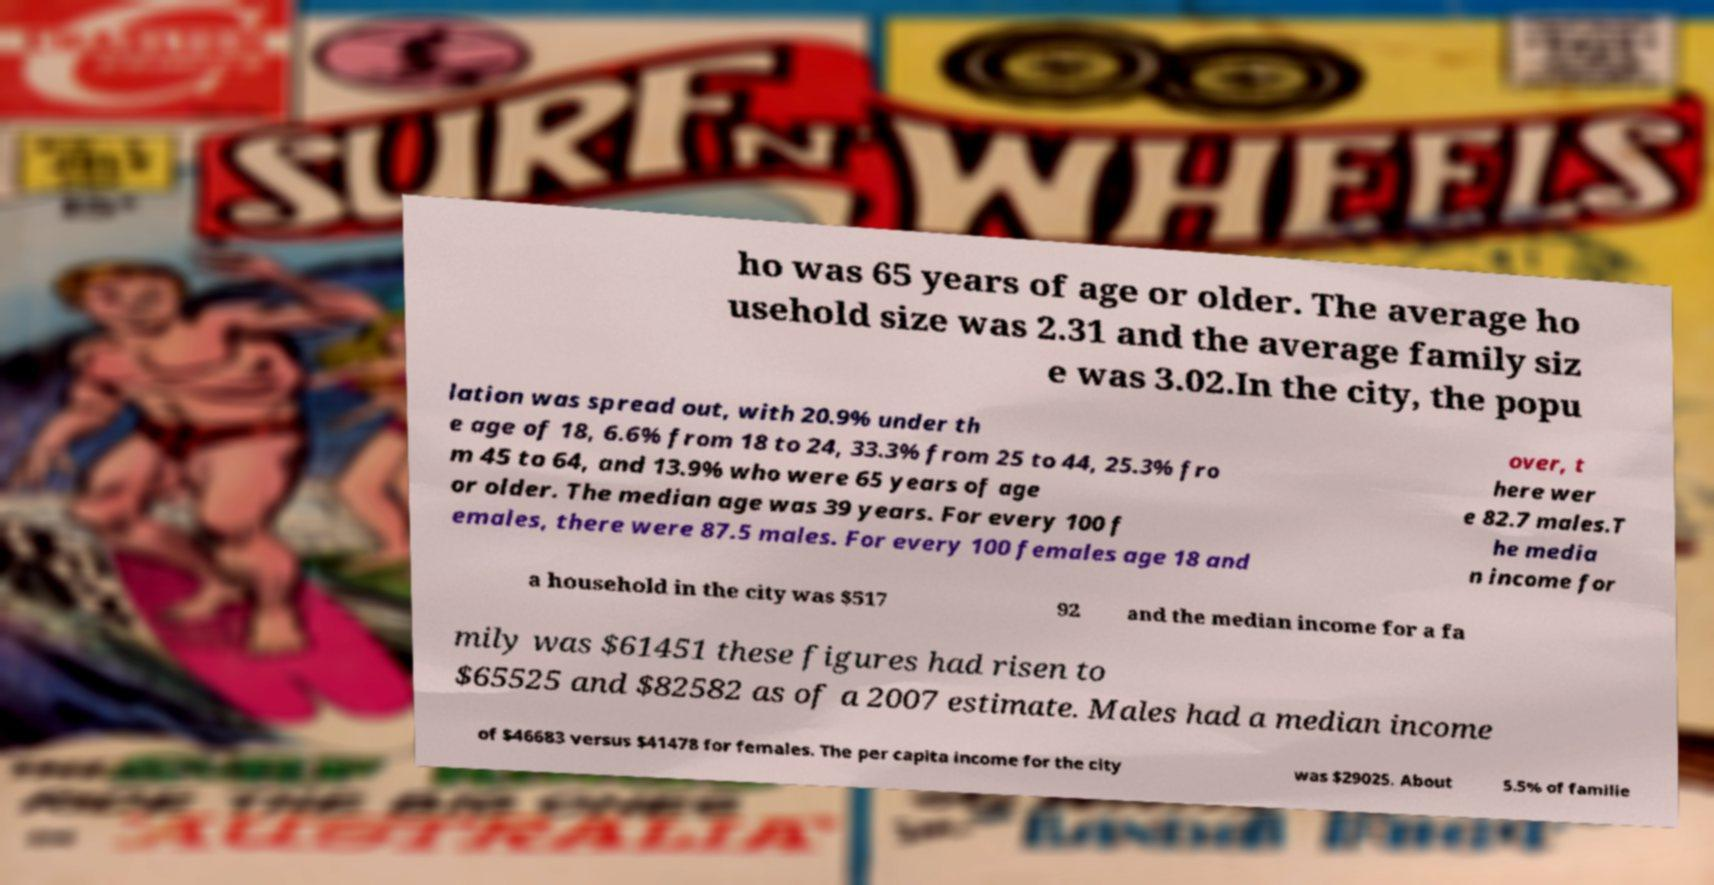Could you assist in decoding the text presented in this image and type it out clearly? ho was 65 years of age or older. The average ho usehold size was 2.31 and the average family siz e was 3.02.In the city, the popu lation was spread out, with 20.9% under th e age of 18, 6.6% from 18 to 24, 33.3% from 25 to 44, 25.3% fro m 45 to 64, and 13.9% who were 65 years of age or older. The median age was 39 years. For every 100 f emales, there were 87.5 males. For every 100 females age 18 and over, t here wer e 82.7 males.T he media n income for a household in the city was $517 92 and the median income for a fa mily was $61451 these figures had risen to $65525 and $82582 as of a 2007 estimate. Males had a median income of $46683 versus $41478 for females. The per capita income for the city was $29025. About 5.5% of familie 